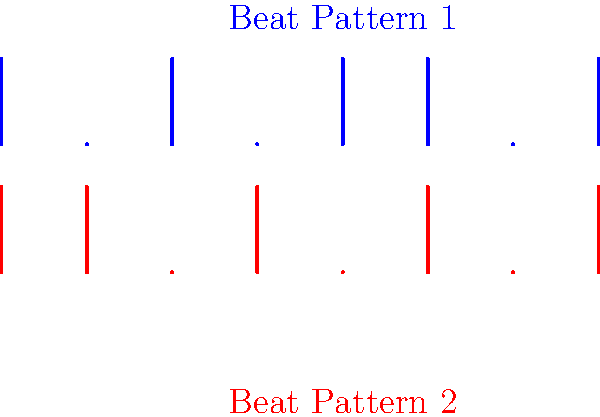Yo, check it! We've got two fresh beat patterns laid down, each with 8 time slots. The blue pattern up top is $\mathbf{a} = [1,0,1,0,1,1,0,1]$, and the red pattern below is $\mathbf{b} = [1,1,0,1,0,1,0,1]$. We wanna measure how similar these beats are. Calculate the dot product $\mathbf{a} \cdot \mathbf{b}$ to quantify their similarity. What's the final score? Alright, let's break this down step by step:

1) The dot product of two vectors $\mathbf{a} = [a_1, a_2, ..., a_n]$ and $\mathbf{b} = [b_1, b_2, ..., b_n]$ is defined as:

   $$\mathbf{a} \cdot \mathbf{b} = \sum_{i=1}^n a_i b_i$$

2) In our case:
   $\mathbf{a} = [1,0,1,0,1,1,0,1]$
   $\mathbf{b} = [1,1,0,1,0,1,0,1]$

3) Let's multiply corresponding elements:
   $(1 \times 1) + (0 \times 1) + (1 \times 0) + (0 \times 1) + (1 \times 0) + (1 \times 1) + (0 \times 0) + (1 \times 1)$

4) Simplifying:
   $1 + 0 + 0 + 0 + 0 + 1 + 0 + 1$

5) Adding up all these terms:
   $1 + 1 + 1 = 3$

The higher the dot product, the more similar the patterns. A score of 3 out of a possible 8 (if the patterns were identical) indicates a moderate similarity between these two beat patterns.
Answer: 3 